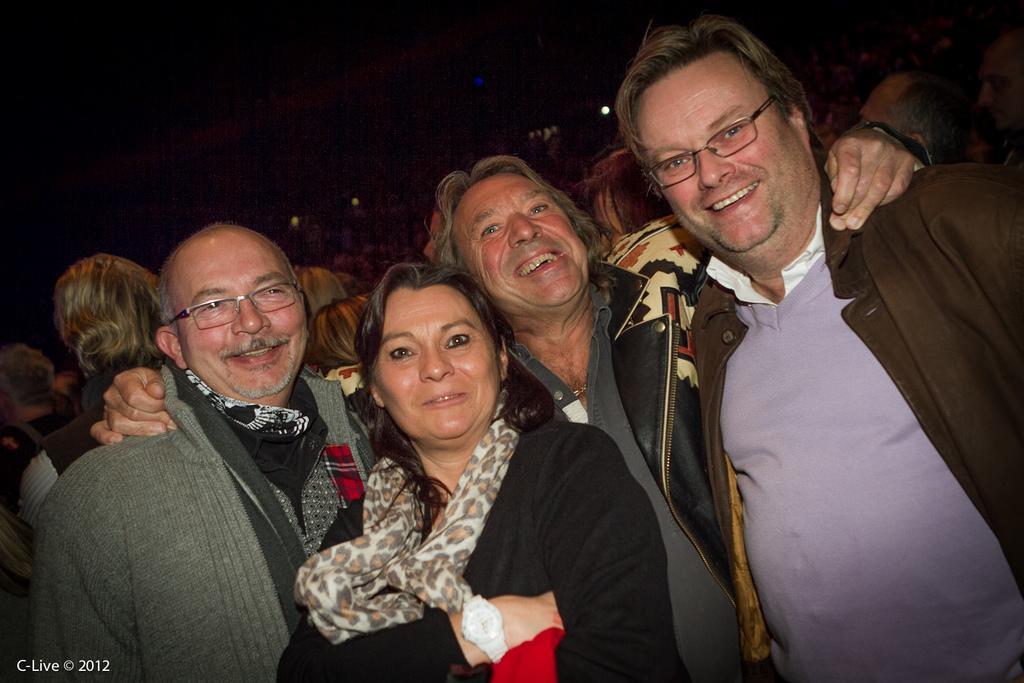Describe this image in one or two sentences. This picture shows few people standing and we see couple of them were sun glasses and we see smile on their faces and lights and we see text at the bottom left corner. 